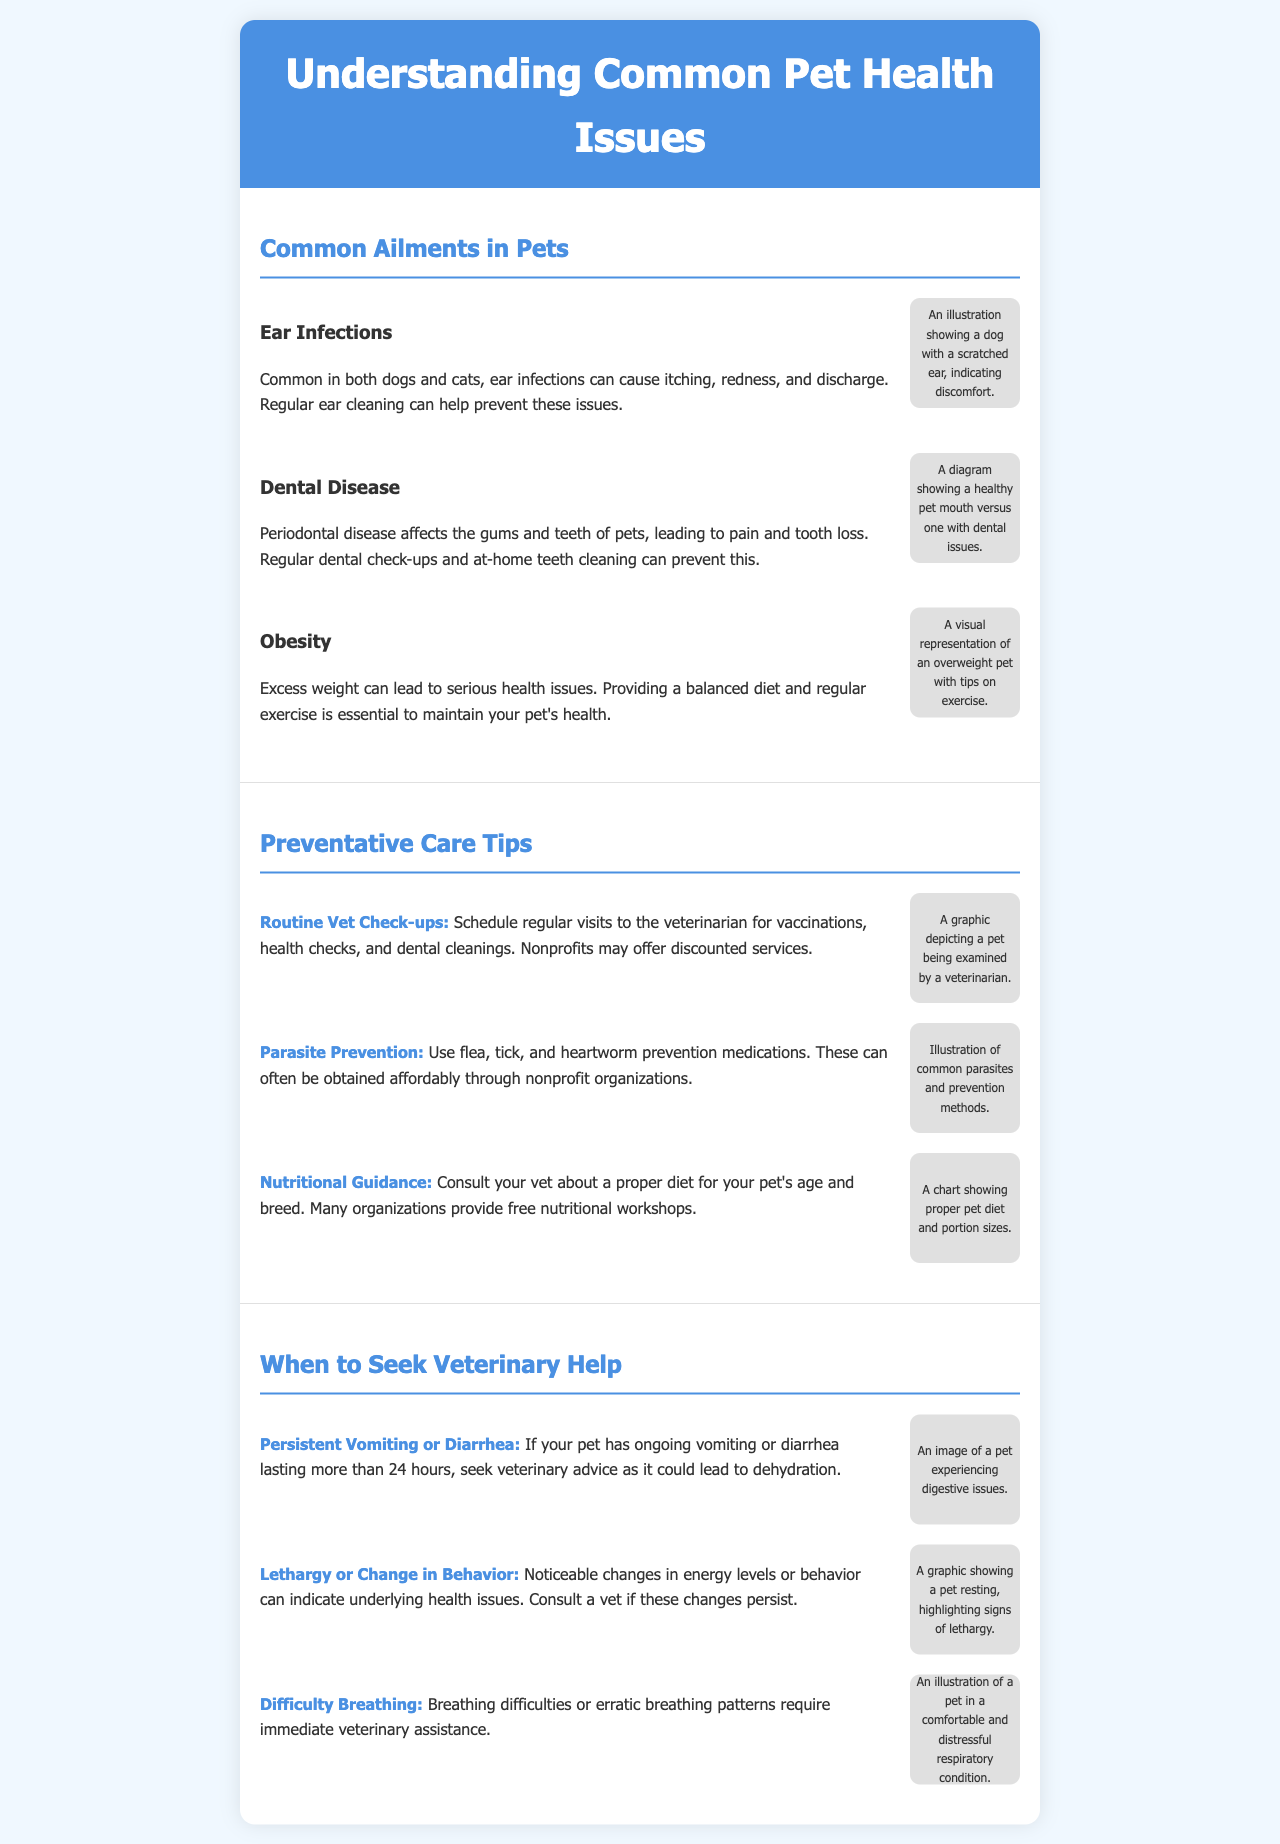What are the common ailments listed for pets? The document lists common ailments including Ear Infections, Dental Disease, and Obesity.
Answer: Ear Infections, Dental Disease, Obesity What preventative care tips are mentioned? The preventative care tips include Routine Vet Check-ups, Parasite Prevention, and Nutritional Guidance.
Answer: Routine Vet Check-ups, Parasite Prevention, Nutritional Guidance When should a pet owner seek veterinary help? The document indicates several signs such as Persistent Vomiting or Diarrhea, Lethargy or Change in Behavior, and Difficulty Breathing.
Answer: Persistent Vomiting or Diarrhea, Lethargy or Change in Behavior, Difficulty Breathing What color is the header background? The header background color is specified in the document as #4a90e2.
Answer: #4a90e2 How many sections are in the brochure? The document features three main sections: Common Ailments in Pets, Preventative Care Tips, and When to Seek Veterinary Help.
Answer: Three What does the tip about nutritional guidance suggest? The tip advises consulting a vet about a proper diet for a pet's age and breed.
Answer: Consult your vet about a proper diet What visual representation is mentioned for obesity? The document describes a visual representation of an overweight pet with tips on exercise for the obesity section.
Answer: Overweight pet with tips on exercise What does the indicator for lethargy signify? The indicator for lethargy indicates that noticeable changes in energy levels or behavior may signal underlying health issues.
Answer: Underlying health issues What is the purpose of the brochure? The purpose of the brochure is to educate pet owners about common health issues, preventative care, and when to seek help.
Answer: Educate pet owners about health issues 